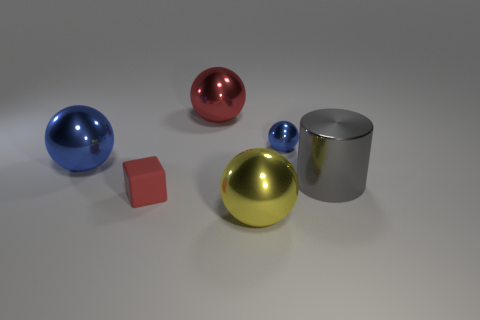Subtract all big spheres. How many spheres are left? 1 Subtract all cubes. How many objects are left? 5 Subtract all brown blocks. How many yellow balls are left? 1 Subtract all blue balls. How many balls are left? 2 Subtract 0 purple blocks. How many objects are left? 6 Subtract 3 spheres. How many spheres are left? 1 Subtract all blue balls. Subtract all green blocks. How many balls are left? 2 Subtract all big objects. Subtract all large blue spheres. How many objects are left? 1 Add 6 tiny shiny objects. How many tiny shiny objects are left? 7 Add 5 yellow matte spheres. How many yellow matte spheres exist? 5 